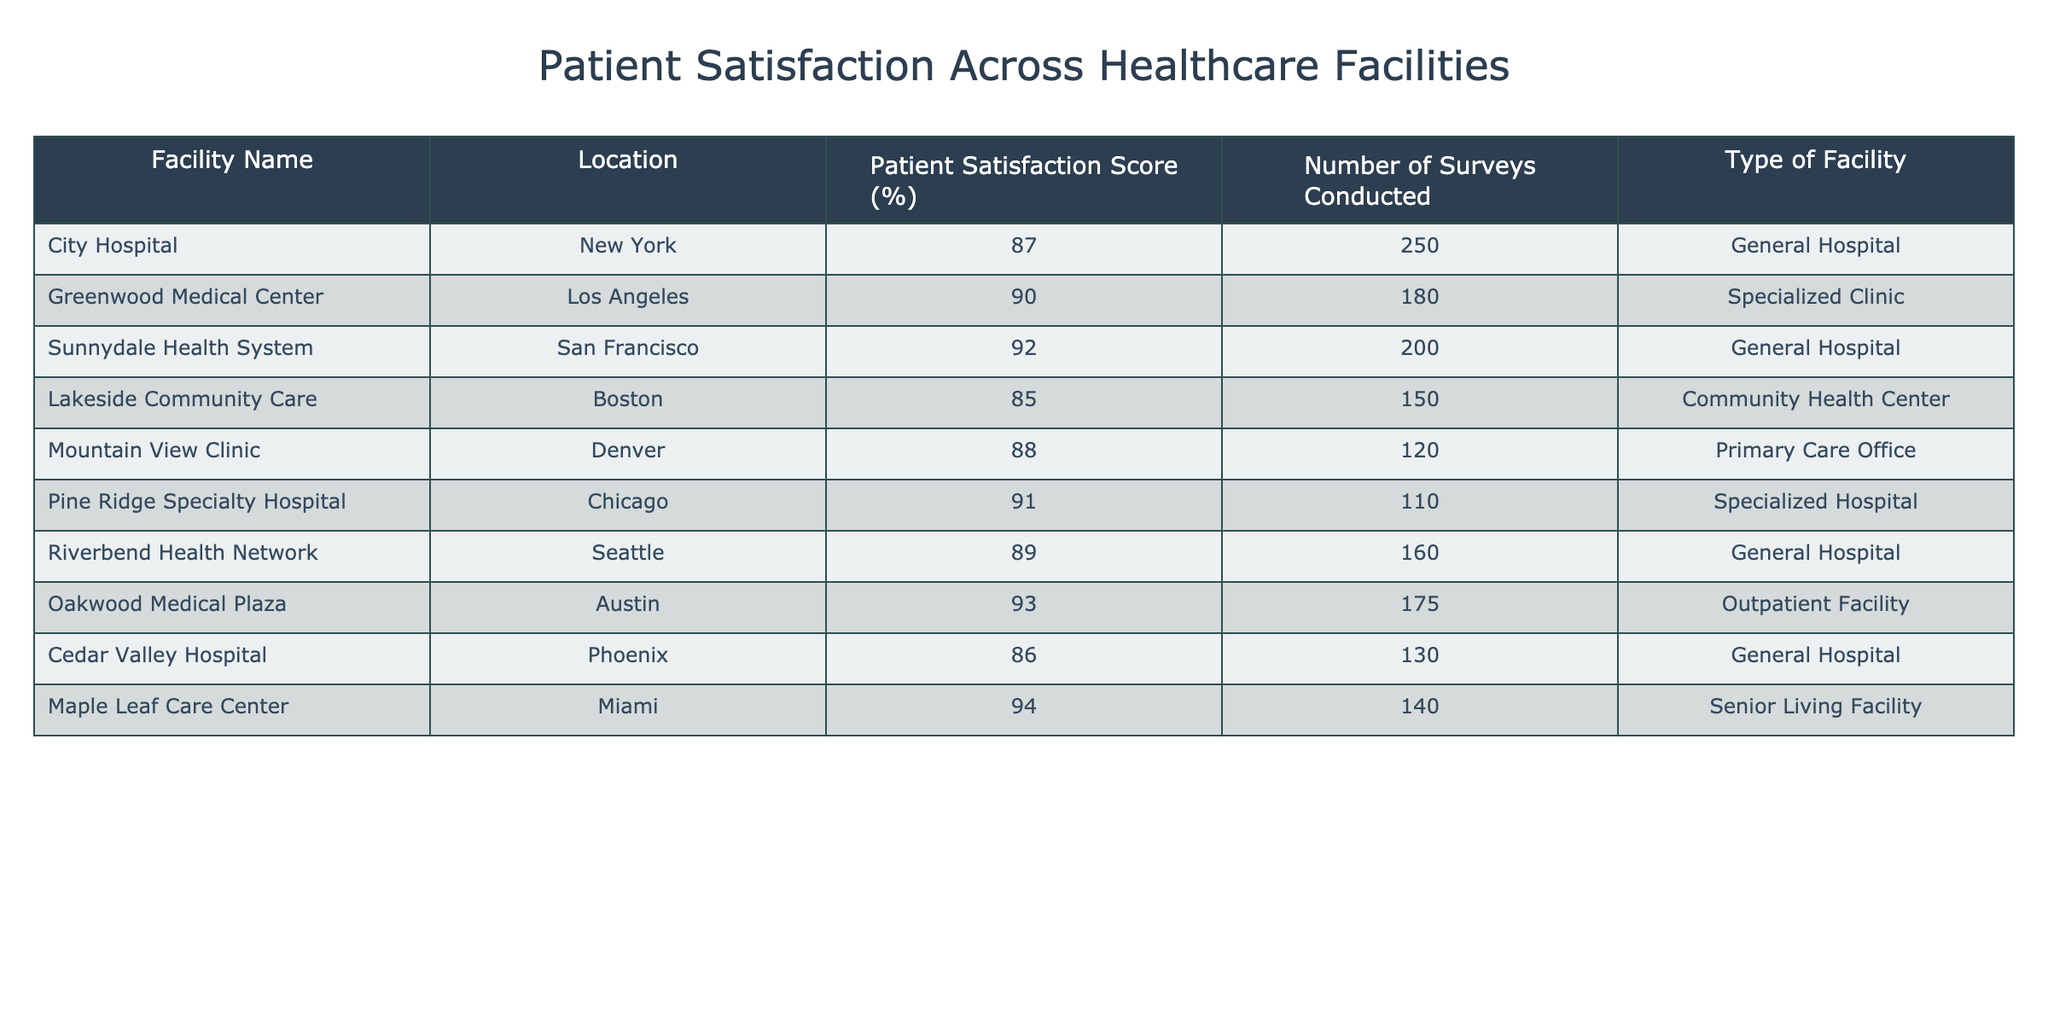What is the patient satisfaction score for City Hospital? The score for City Hospital is directly listed in the table under the "Patient Satisfaction Score (%)" column. According to the data, it shows 87%.
Answer: 87% Which facility has the highest patient satisfaction score? To determine this, we can compare all the scores listed in the table. The highest value is 94%, which corresponds to the Maple Leaf Care Center.
Answer: Maple Leaf Care Center How many surveys were conducted at Oakwood Medical Plaza? The number of surveys conducted at Oakwood Medical Plaza is found in the "Number of Surveys Conducted" column. It states 175 surveys were conducted.
Answer: 175 What is the average patient satisfaction score across all facilities? To calculate the average, we sum up all the patient satisfaction scores and divide by the number of facilities. The sum of all scores is 87 + 90 + 92 + 85 + 88 + 91 + 89 + 93 + 86 + 94 = 915; there are 10 facilities, so the average is 915 / 10 = 91.5%.
Answer: 91.5% Is there a facility located in San Francisco? By scanning the "Location" column, we find that Sunnydale Health System is located in San Francisco, confirming the existence of a facility there.
Answer: Yes Which type of facility has the lowest patient satisfaction score? We can determine the type associated with the lowest score. The table indicates that Cedar Valley Hospital, a General Hospital, has the lowest score of 86%.
Answer: General Hospital Are there more specialized facilities or general hospitals in the list? By counting the types in the "Type of Facility" column, we find there are 4 General Hospitals (City Hospital, Sunnydale Health System, Riverbend Health Network, Cedar Valley Hospital) and 3 Specialized facilities (Greenwood Medical Center, Pine Ridge Specialty Hospital, and Oakwood Medical Plaza). Therefore, there are more General Hospitals.
Answer: More General Hospitals What is the difference in patient satisfaction scores between the highest and lowest scoring facilities? The highest score is 94% from Maple Leaf Care Center, and the lowest is 86% from Cedar Valley Hospital. The difference is calculated as 94% - 86% = 8%.
Answer: 8% How many facilities have a patient satisfaction score of 90% or higher? By counting the scores that meet the criteria, we find the following facilities have scores of 90% or above: Greenwood Medical Center (90%), Sunnydale Health System (92%), Pine Ridge Specialty Hospital (91%), Oakwood Medical Plaza (93%), and Maple Leaf Care Center (94%). That totals 5 facilities.
Answer: 5 